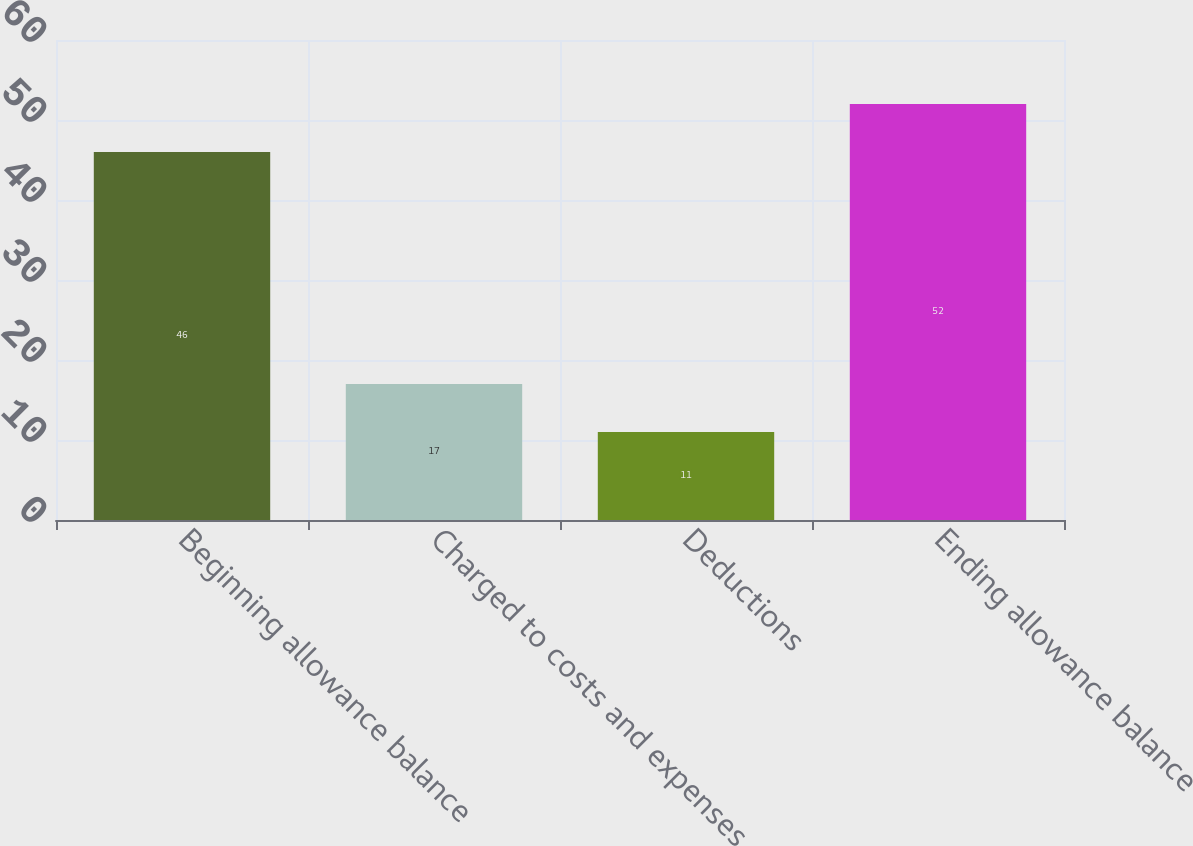Convert chart. <chart><loc_0><loc_0><loc_500><loc_500><bar_chart><fcel>Beginning allowance balance<fcel>Charged to costs and expenses<fcel>Deductions<fcel>Ending allowance balance<nl><fcel>46<fcel>17<fcel>11<fcel>52<nl></chart> 